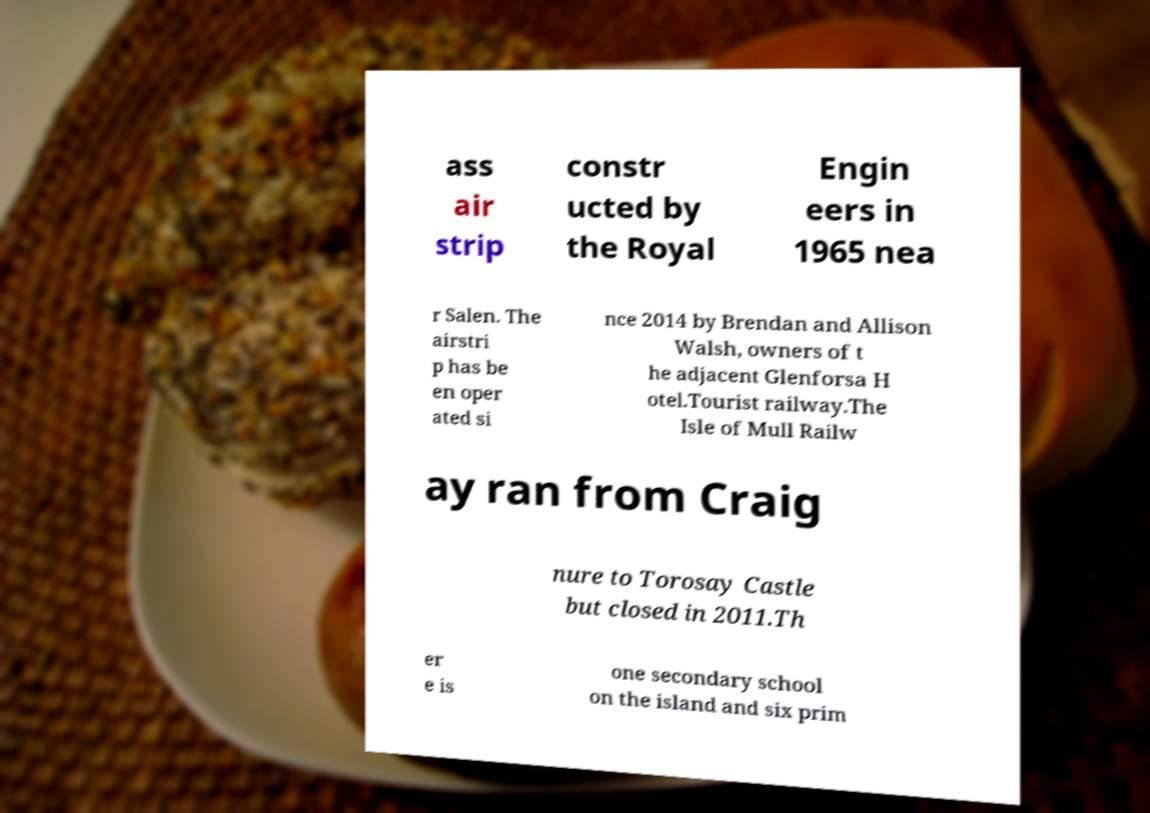Please read and relay the text visible in this image. What does it say? ass air strip constr ucted by the Royal Engin eers in 1965 nea r Salen. The airstri p has be en oper ated si nce 2014 by Brendan and Allison Walsh, owners of t he adjacent Glenforsa H otel.Tourist railway.The Isle of Mull Railw ay ran from Craig nure to Torosay Castle but closed in 2011.Th er e is one secondary school on the island and six prim 